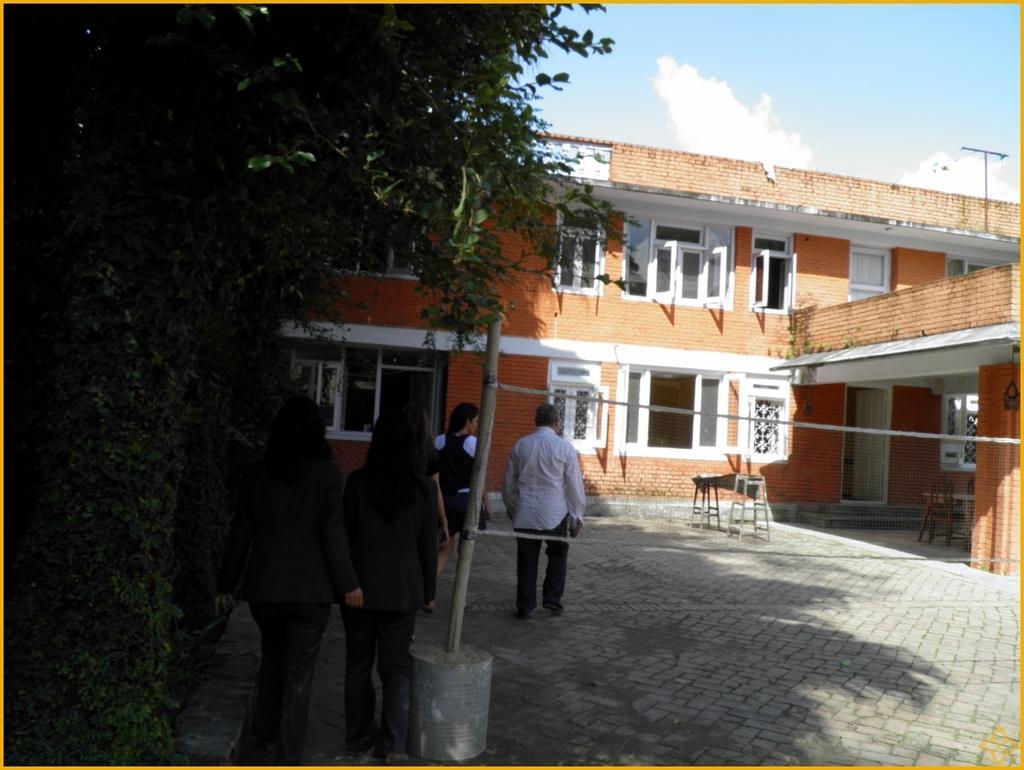How would you summarize this image in a sentence or two? There are four persons. Here we can see trees, building, doors, windows, and table. In the background there is sky. 